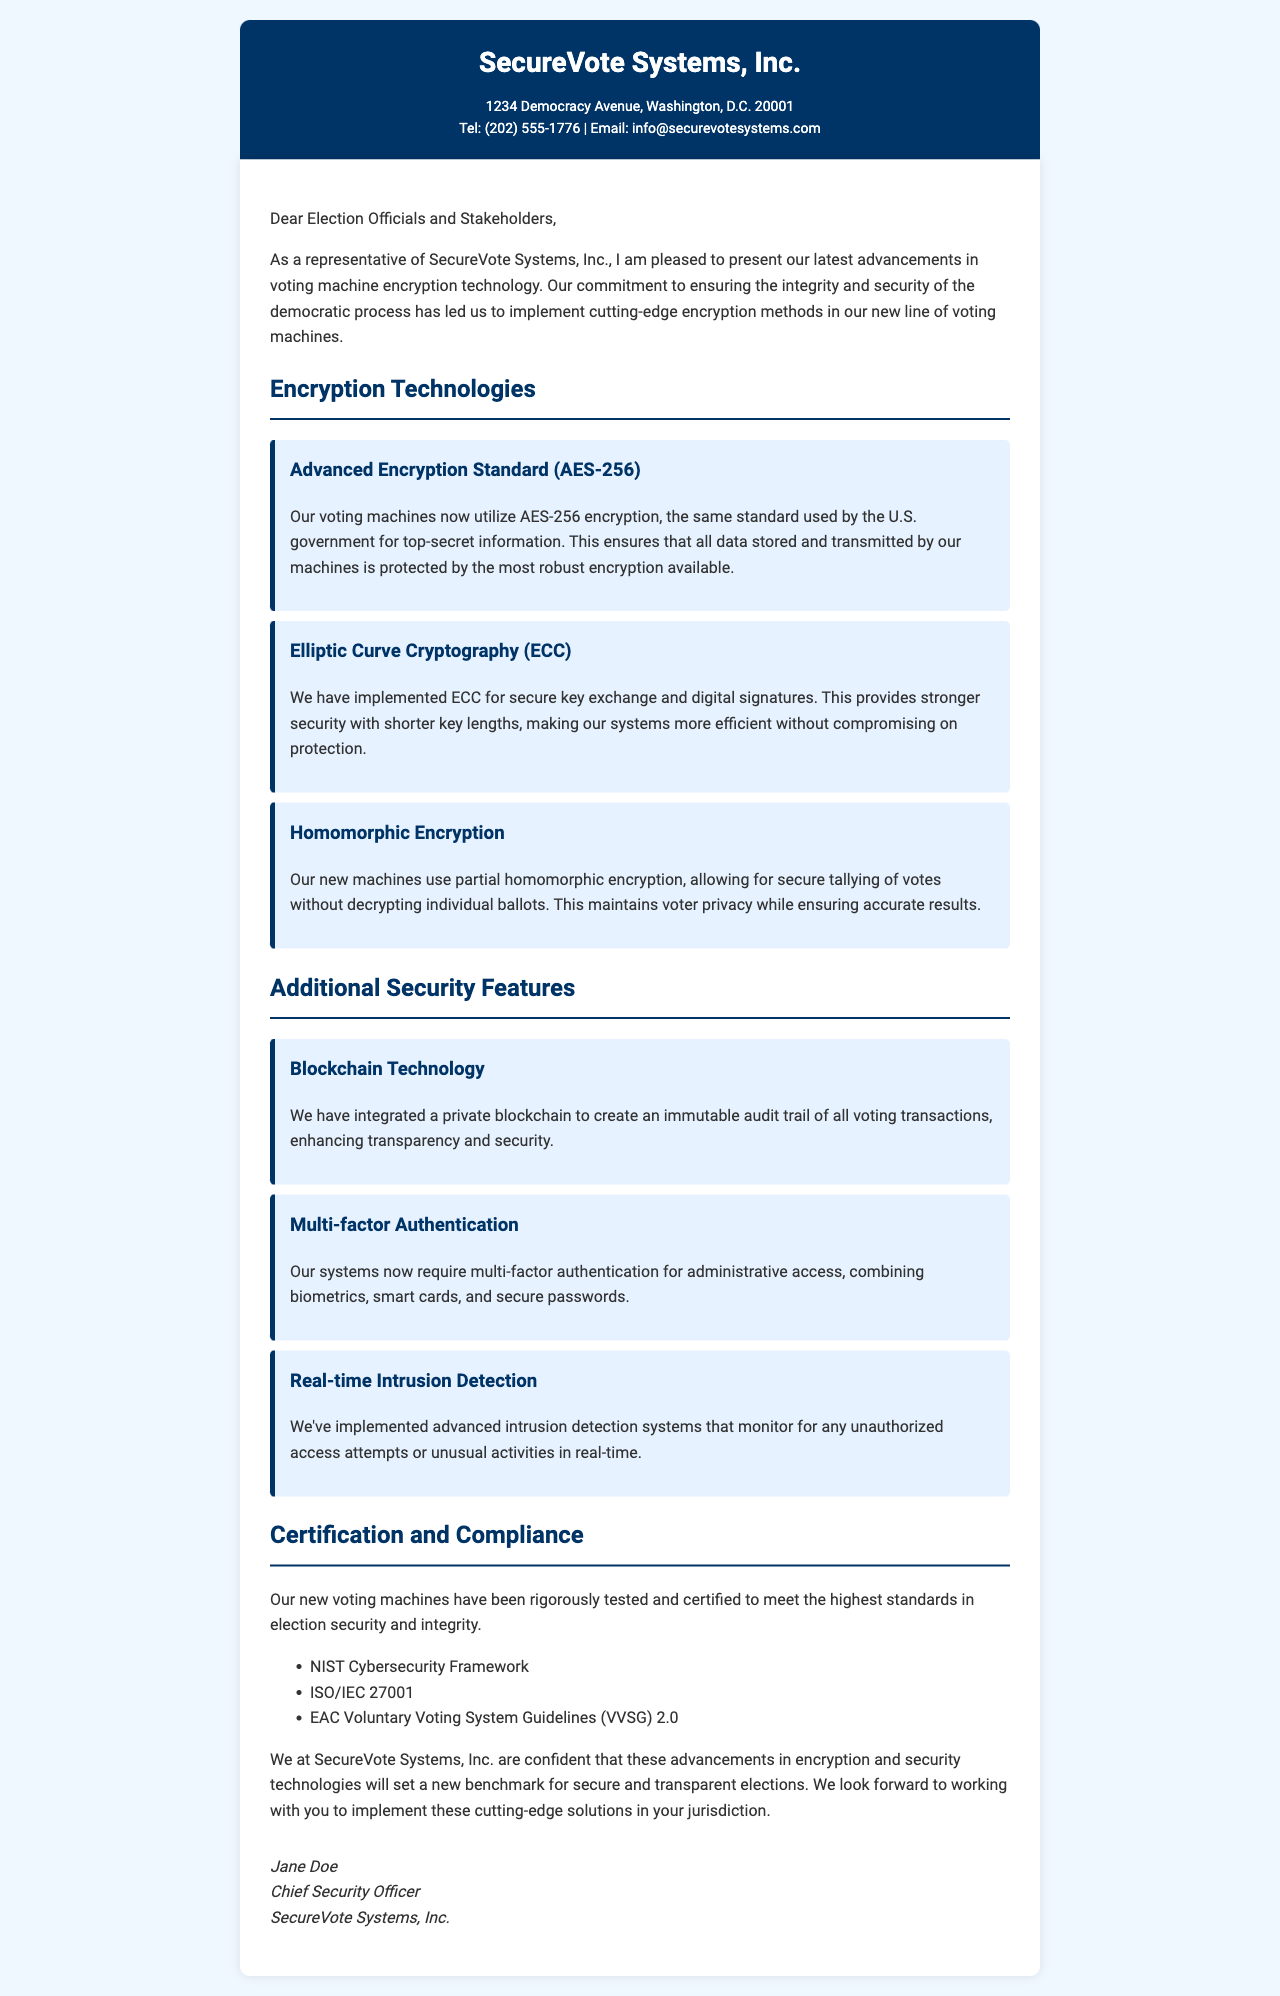What is the name of the company? The name of the company is listed in the letter header.
Answer: SecureVote Systems, Inc What is the encryption standard used by the voting machines? The encryption standard is mentioned in the encryption technologies section.
Answer: AES-256 Which cryptographic method is used for secure key exchange? The letter details various encryption technologies, including a method for secure key exchange.
Answer: Elliptic Curve Cryptography (ECC) How many additional security features are listed in the document? The document includes a section on additional security features and provides a list.
Answer: Three What certification framework is mentioned in the compliance section? The letter lists multiple certification standards, one of which is a framework.
Answer: NIST Cybersecurity Framework What is the primary benefit of homomorphic encryption detailed in the letter? The reason for using homomorphic encryption is described in the encryption technologies section.
Answer: Voter privacy Who signed the letter? The signature section contains the name of the person who signed the letter.
Answer: Jane Doe What is the main goal of SecureVote Systems, Inc. according to the closing paragraph? The closing paragraph summarizes the company's commitment to a specific goal regarding elections.
Answer: Secure and transparent elections Which security feature requires multiple forms of verification? The additional security features section discusses a feature requiring different verification methods.
Answer: Multi-factor Authentication 